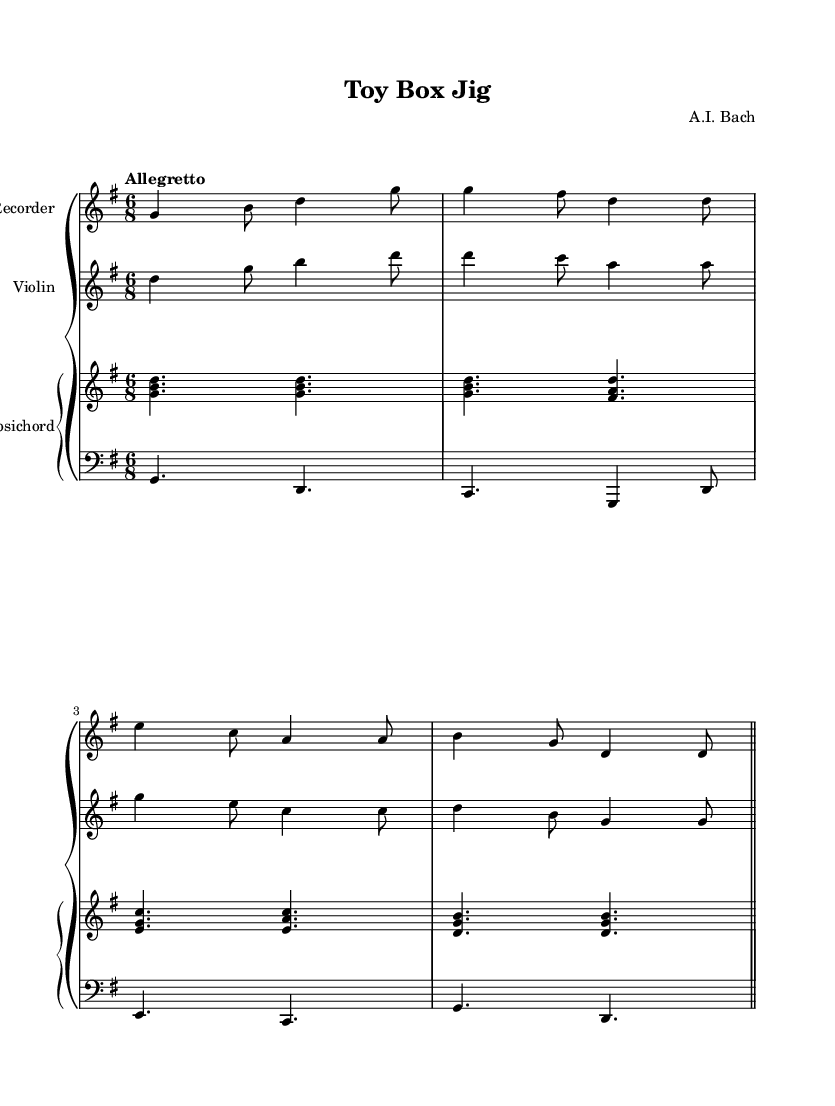What is the key signature of this music? The key signature is G major, which has one sharp (F sharp). This is indicated at the beginning of the staff.
Answer: G major What is the time signature of the piece? The time signature is six-eight, which is shown at the beginning of the score by the numbers 6 and 8. This means there are six eighth notes per measure.
Answer: 6/8 What is the tempo marking for this composition? The tempo marking is "Allegretto," which suggests a moderately fast tempo. It indicates how quickly the piece should be played.
Answer: Allegretto How many measures are in the piece? There are eight measures in total, which can be counted by identifying the bar lines that separate the measures.
Answer: 8 Which instruments are featured in this music? The instruments featured include the recorder, violin, and harpsichord, all specified at the start of each staff and in the piano staff.
Answer: Recorder, violin, harpsichord What is the term used to describe the lively and cheerful style of this music? The lively and cheerful style of the music can be described as "Jig," which is indicated in the title. This suggests a particular dancing style common in Baroque music.
Answer: Jig Which instrument plays the melody in the first section? The melody in the first section is primarily played by the recorder, as indicated by its part being at the top of the score and containing the primary melodic line.
Answer: Recorder 